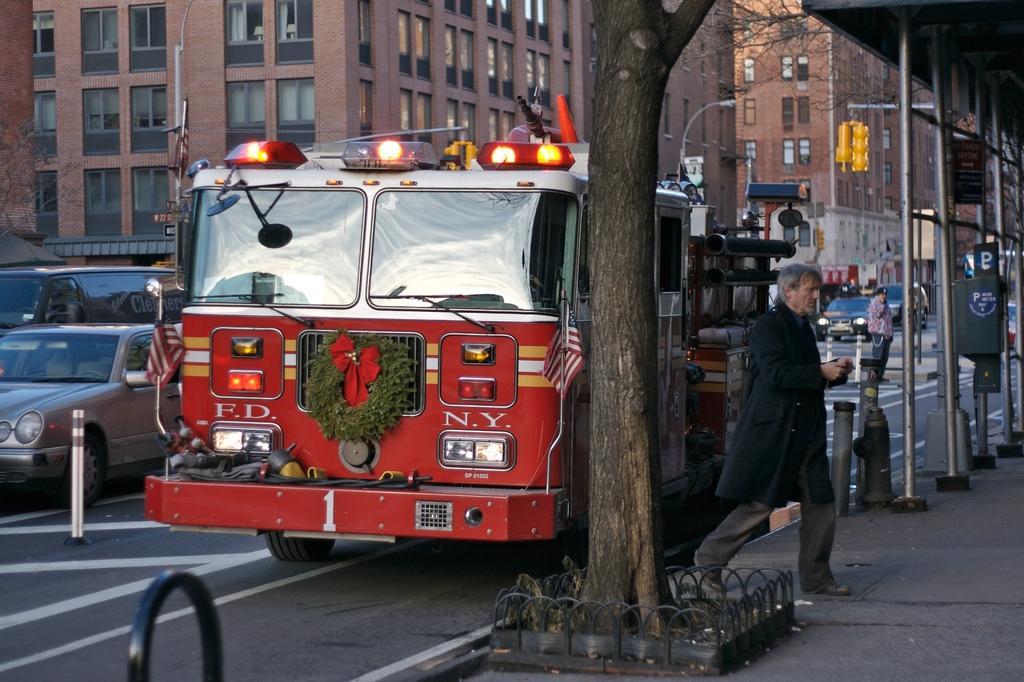In one or two sentences, can you explain what this image depicts? In the middle of the image we can see a tree. Behind the tree there are some vehicles on the road and few people are walking and there are some poles and trees and buildings. 